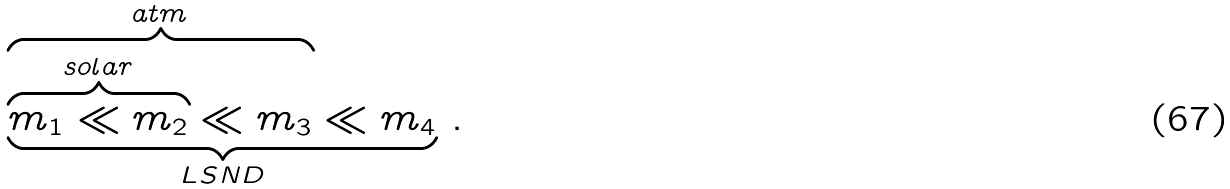<formula> <loc_0><loc_0><loc_500><loc_500>\underbrace { \overbrace { \overbrace { m _ { 1 } \ll m _ { 2 } } ^ { s o l a r } \ll m _ { 3 } } ^ { a t m } \ll m _ { 4 } } _ { L S N D } \, .</formula> 